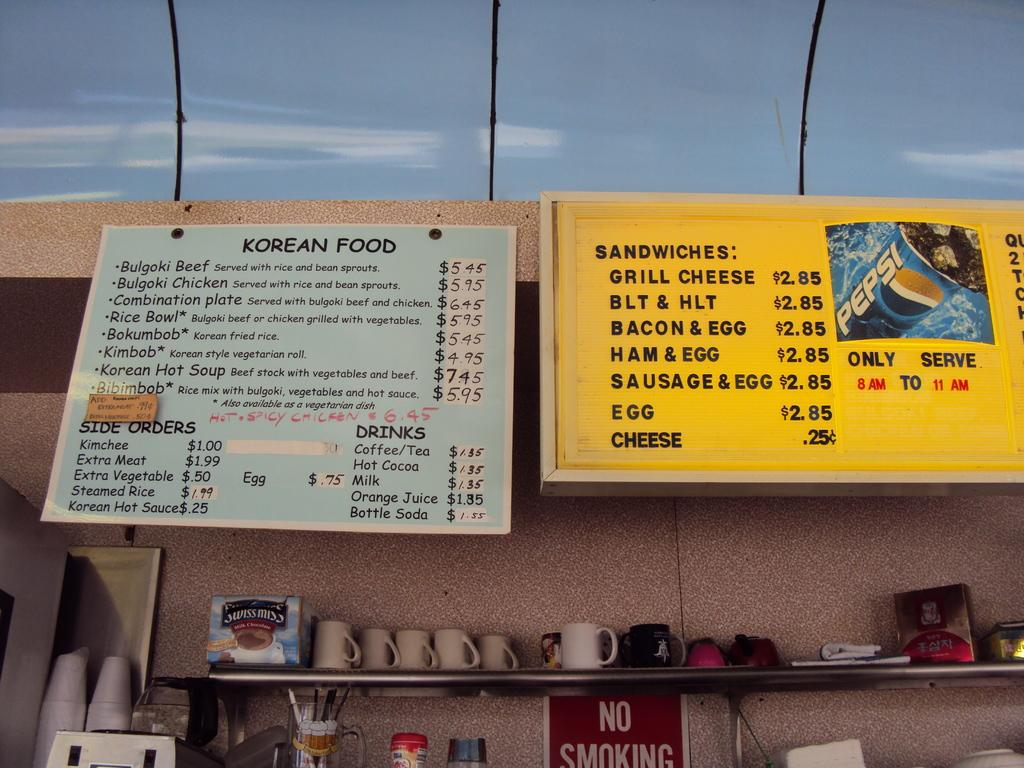<image>
Offer a succinct explanation of the picture presented. a menu that has the word sandwiches on it 